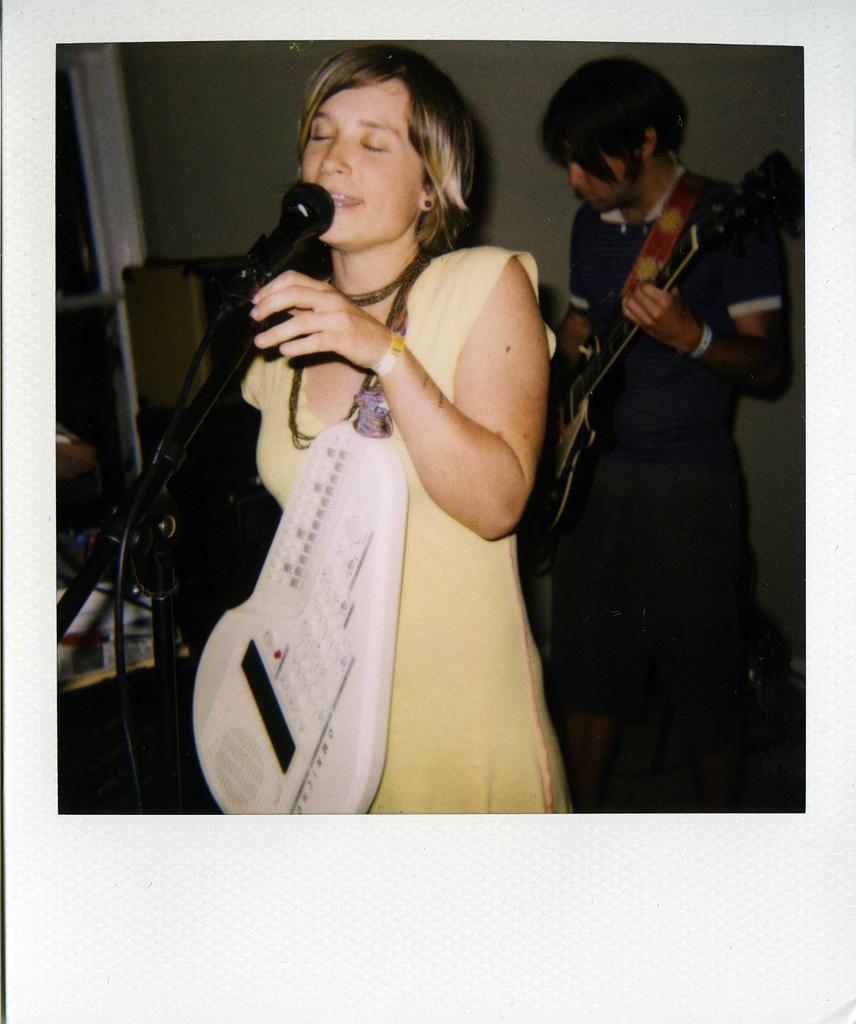Can you describe this image briefly? In this picture I can see a photo. There are two persons standing. I can see a person holding a guitar, mike with a mike stand and some other objects, and in the background there is a wall. 